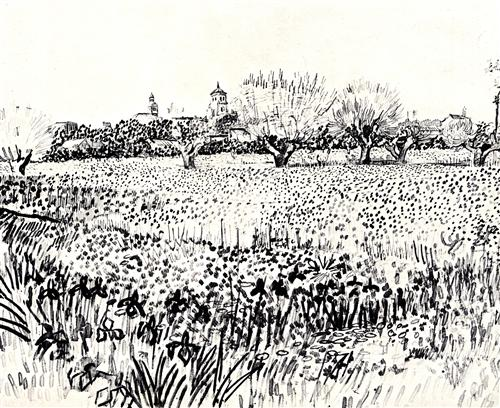Create a short story based on this image. In a quaint village nestled between fields of wildflowers and serene trees, lived a humble artist named Anne. Every day at dawn, she would sit at the edge of the field, sketching the landscape with a keen eye for detail. The villagers admired her works that, despite being in black and white, captured the soul of their home. One year, a severe drought threatened the beauty of the land, turning the lush field into a barren expanse. Inspired by Anne’s art, the villagers rallied together, conserving water and planting new seeds with hope and care. Their efforts paid off, and by the next spring, the field was more vibrant than ever. Anne’s sketches stood as a testament to the power of community and resilience, reminding everyone of the beauty they can protect and nurture together. What if the field could cast a spell? What would it do? If the field could cast a spell, it would be one of tranquility and inspiration. Anyone who stepped into the field would feel an overwhelming sense of peace, their worries and stresses melting away. The spell would rekindle their creativity, whether they were poets, painters, or merely dreamers. People who entered the field would leave with renewed vigor and ideas, inspired by the harmony and beauty surrounding them. The village would become a haven for artists and thinkers around the world, drawn to the magical field that promised revitalization and artistic brilliance. 